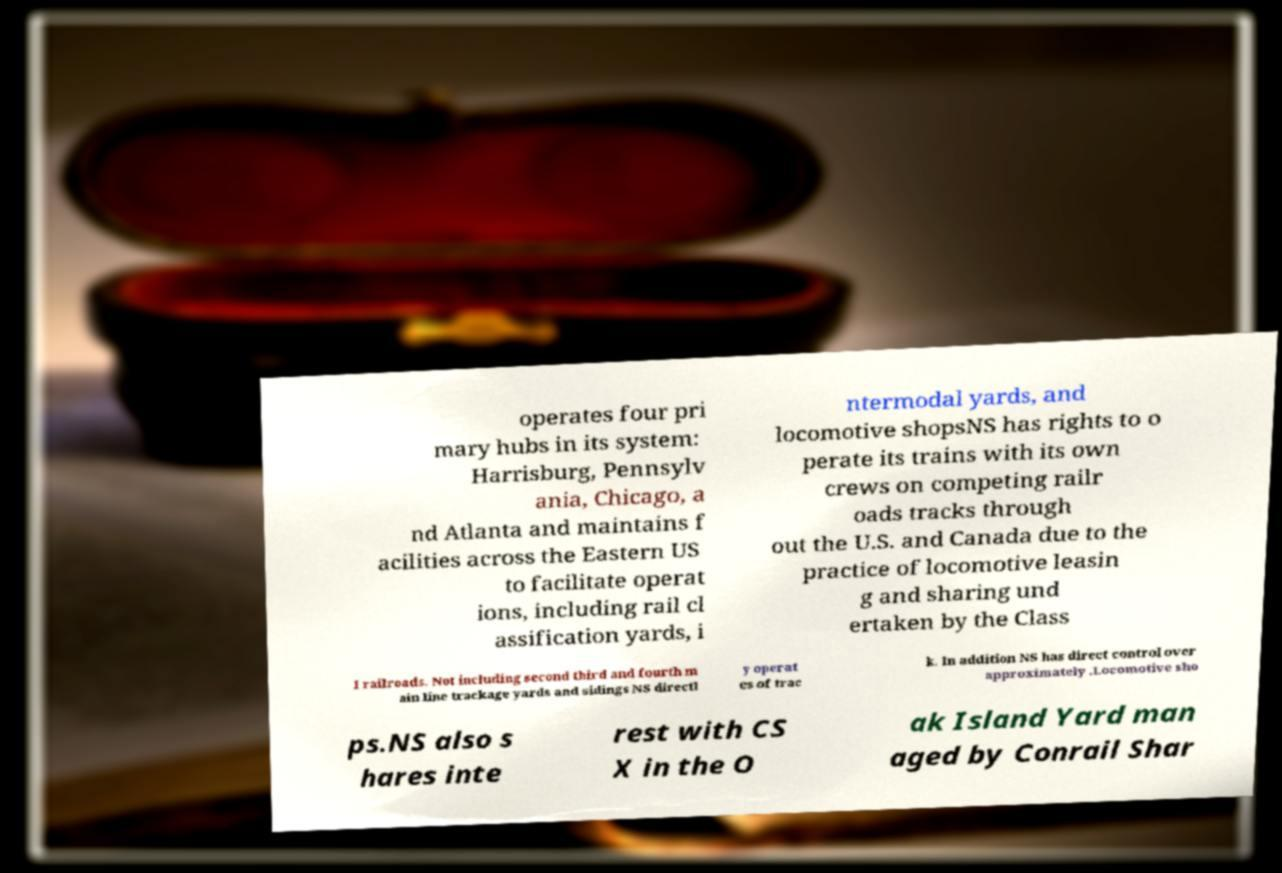Could you extract and type out the text from this image? operates four pri mary hubs in its system: Harrisburg, Pennsylv ania, Chicago, a nd Atlanta and maintains f acilities across the Eastern US to facilitate operat ions, including rail cl assification yards, i ntermodal yards, and locomotive shopsNS has rights to o perate its trains with its own crews on competing railr oads tracks through out the U.S. and Canada due to the practice of locomotive leasin g and sharing und ertaken by the Class I railroads. Not including second third and fourth m ain line trackage yards and sidings NS directl y operat es of trac k. In addition NS has direct control over approximately .Locomotive sho ps.NS also s hares inte rest with CS X in the O ak Island Yard man aged by Conrail Shar 